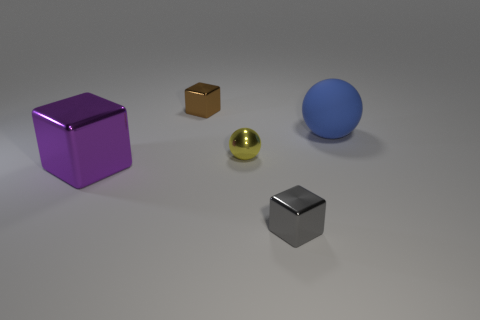There is a gray shiny thing that is the same size as the brown thing; what shape is it?
Provide a succinct answer. Cube. What number of objects are either large cyan matte cylinders or tiny things that are on the left side of the small yellow metallic ball?
Your answer should be compact. 1. Do the small block in front of the large blue rubber thing and the big object that is behind the big cube have the same material?
Offer a very short reply. No. What number of green objects are either small metallic objects or big matte cylinders?
Make the answer very short. 0. What size is the blue sphere?
Make the answer very short. Large. Are there more shiny objects that are in front of the large blue rubber thing than large blue objects?
Give a very brief answer. Yes. There is a blue sphere; how many big blue rubber things are behind it?
Offer a terse response. 0. Are there any yellow balls of the same size as the brown shiny object?
Keep it short and to the point. Yes. What is the color of the big thing that is the same shape as the small yellow metallic thing?
Make the answer very short. Blue. There is a thing behind the rubber thing; is it the same size as the ball that is on the right side of the tiny gray metal object?
Make the answer very short. No. 